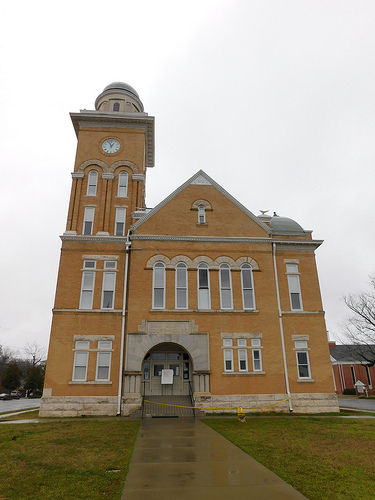<image>
Is the pipe on the wall? Yes. Looking at the image, I can see the pipe is positioned on top of the wall, with the wall providing support. Where is the sidewalk in relation to the wall? Is it under the wall? No. The sidewalk is not positioned under the wall. The vertical relationship between these objects is different. 